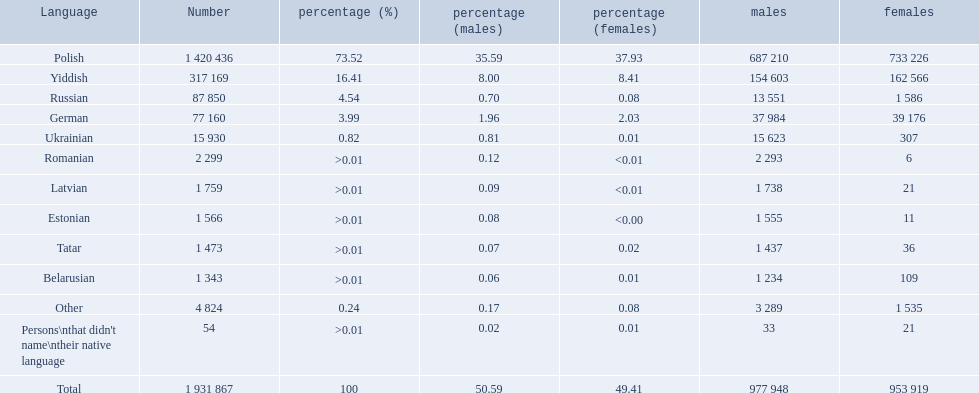What are the languages of the warsaw governorate? Polish, Yiddish, Russian, German, Ukrainian, Romanian, Latvian, Estonian, Tatar, Belarusian, Other. Can you give me this table in json format? {'header': ['Language', 'Number', 'percentage (%)', 'percentage (males)', 'percentage (females)', 'males', 'females'], 'rows': [['Polish', '1 420 436', '73.52', '35.59', '37.93', '687 210', '733 226'], ['Yiddish', '317 169', '16.41', '8.00', '8.41', '154 603', '162 566'], ['Russian', '87 850', '4.54', '0.70', '0.08', '13 551', '1 586'], ['German', '77 160', '3.99', '1.96', '2.03', '37 984', '39 176'], ['Ukrainian', '15 930', '0.82', '0.81', '0.01', '15 623', '307'], ['Romanian', '2 299', '>0.01', '0.12', '<0.01', '2 293', '6'], ['Latvian', '1 759', '>0.01', '0.09', '<0.01', '1 738', '21'], ['Estonian', '1 566', '>0.01', '0.08', '<0.00', '1 555', '11'], ['Tatar', '1 473', '>0.01', '0.07', '0.02', '1 437', '36'], ['Belarusian', '1 343', '>0.01', '0.06', '0.01', '1 234', '109'], ['Other', '4 824', '0.24', '0.17', '0.08', '3 289', '1 535'], ["Persons\\nthat didn't name\\ntheir native language", '54', '>0.01', '0.02', '0.01', '33', '21'], ['Total', '1 931 867', '100', '50.59', '49.41', '977 948', '953 919']]} What is the percentage of polish? 73.52. What is the next highest amount? 16.41. What is the language with this amount? Yiddish. 